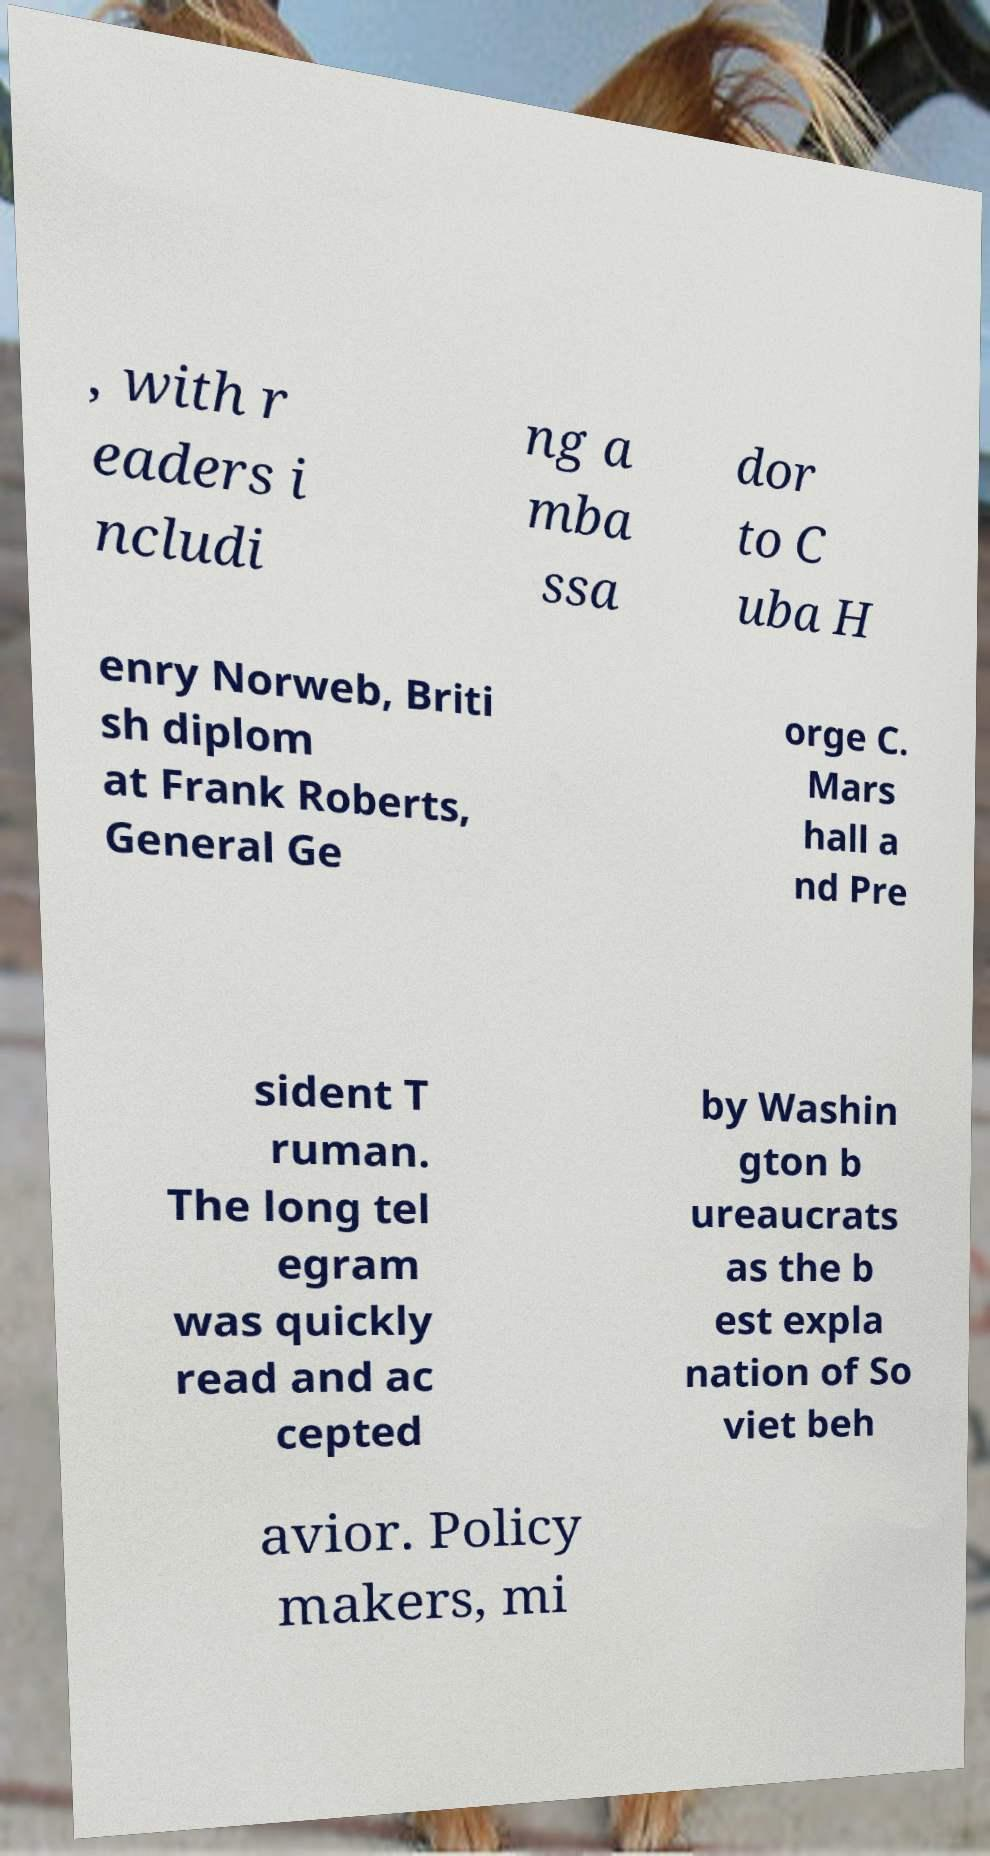Please read and relay the text visible in this image. What does it say? , with r eaders i ncludi ng a mba ssa dor to C uba H enry Norweb, Briti sh diplom at Frank Roberts, General Ge orge C. Mars hall a nd Pre sident T ruman. The long tel egram was quickly read and ac cepted by Washin gton b ureaucrats as the b est expla nation of So viet beh avior. Policy makers, mi 